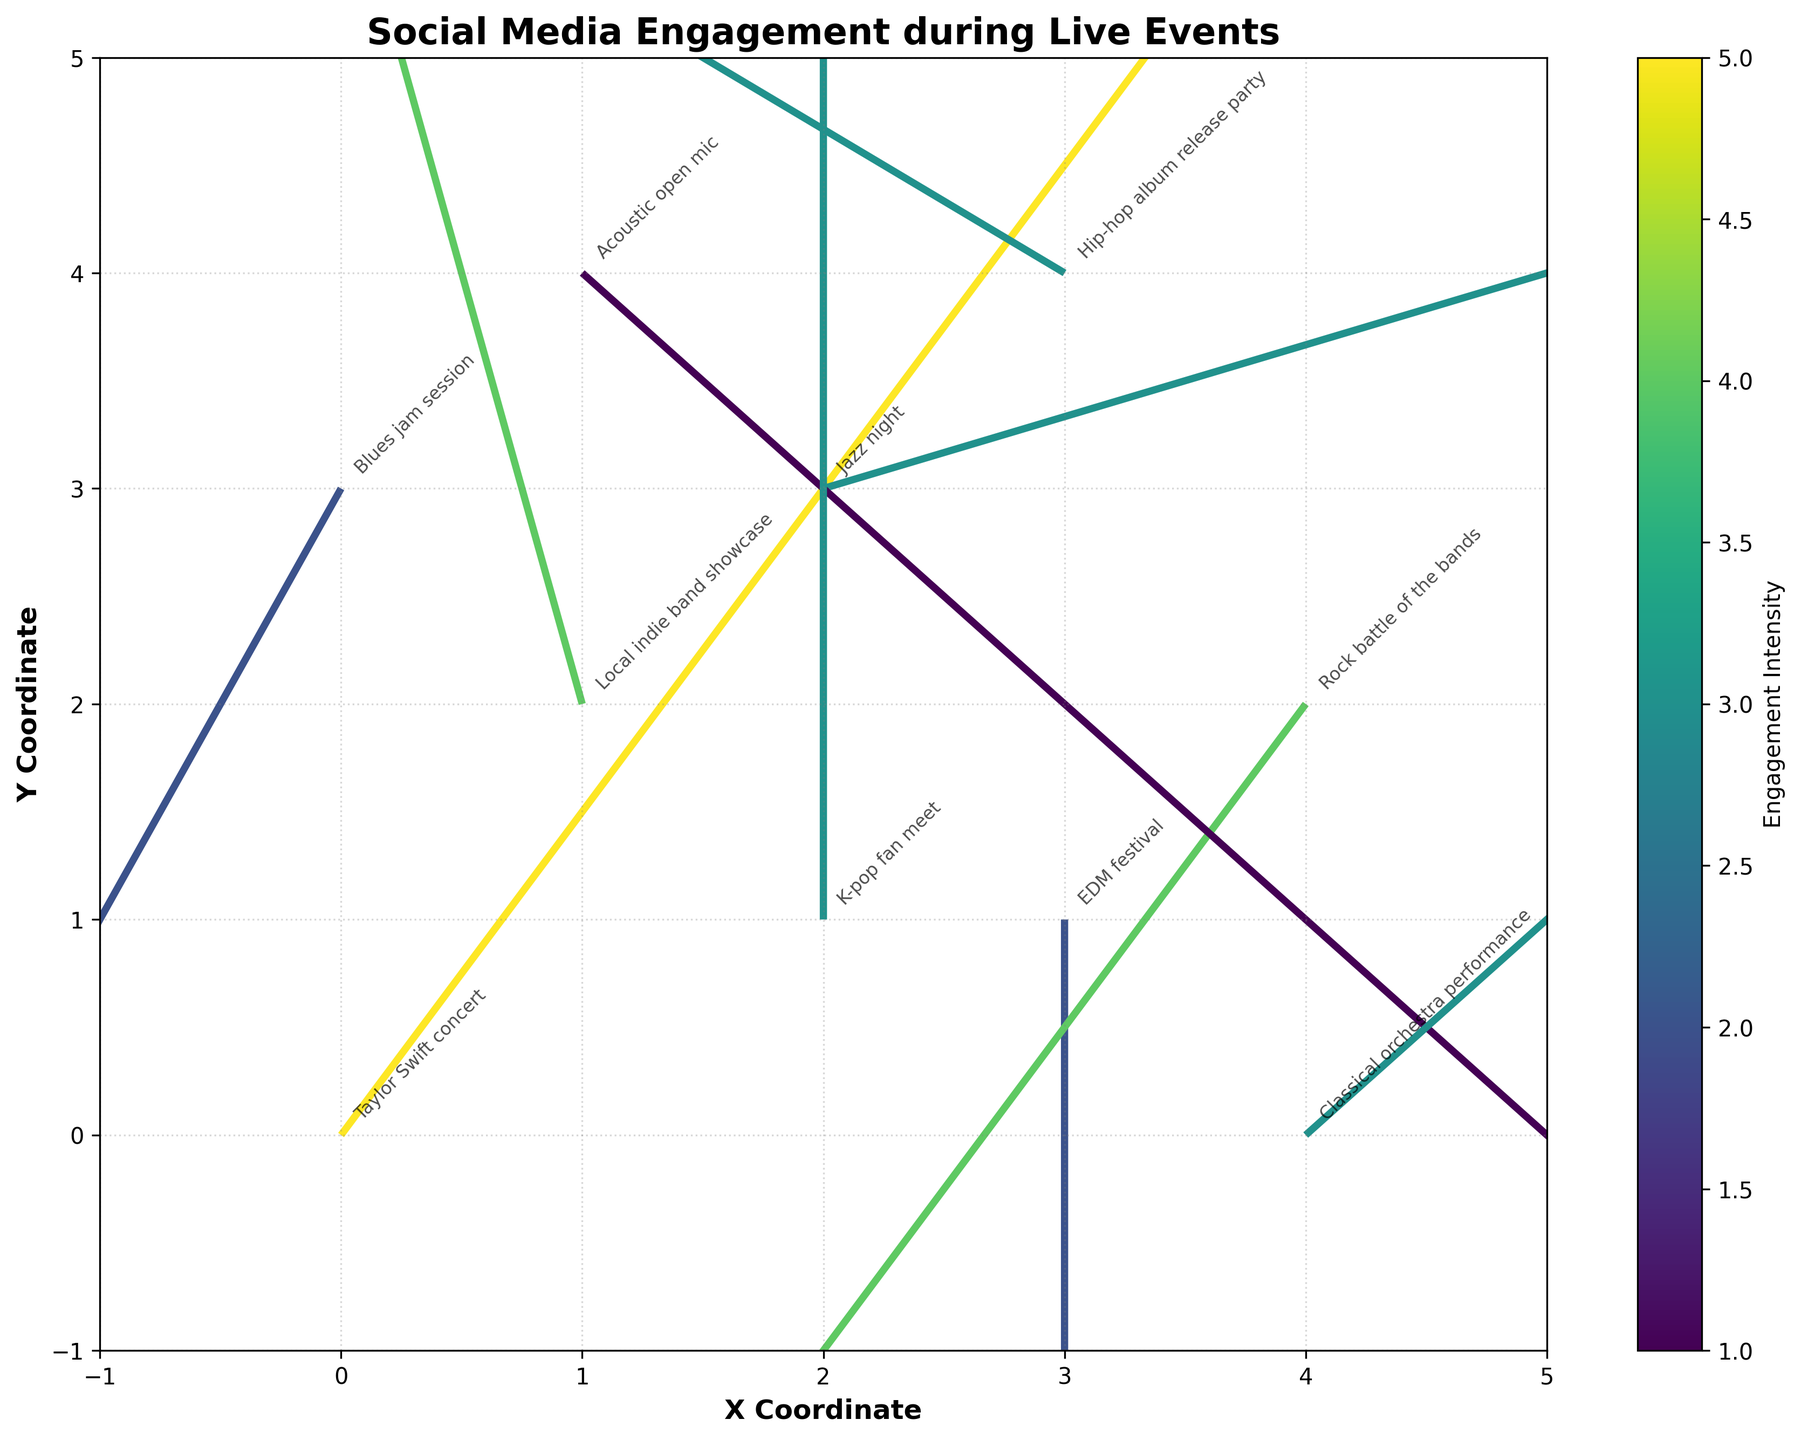What is the title of the plot? The title is located at the top of the plot and is written in a larger, bold font. It reads "Social Media Engagement during Live Events" in the given code.
Answer: Social Media Engagement during Live Events How many data points are represented in the plot? Each data point is represented by a quiver (arrow) on the plot. By counting all the arrows, we can determine the number of data points. There are 10 arrows, so there are 10 data points.
Answer: 10 What event has the highest engagement intensity? The color intensity helps to identify the magnitude of engagement, and each quiver is colored according to its magnitude. By looking closely at the color scale, we can see that the Taylor Swift concert has the highest magnitude of 5.
Answer: Taylor Swift concert Which events are represented in the plot? Each event is labeled on the plot with annotations. By reading these labels, we can identify all the events: Taylor Swift concert, Local indie band showcase, EDM festival, Jazz night, Rock battle of the bands, Acoustic open mic, Hip-hop album release party, Classical orchestra performance, K-pop fan meet, and Blues jam session.
Answer: Taylor Swift concert, Local indie band showcase, EDM festival, Jazz night, Rock battle of the bands, Acoustic open mic, Hip-hop album release party, Classical orchestra performance, K-pop fan meet, Blues jam session Which event has the largest upward social media interaction? Upward social media interaction is indicated by the upward direction of the quiver (positive v component). By inspecting the arrows, we see that the Local indie band showcase has the largest upward vector, with a v component of 4.
Answer: Local indie band showcase Compare the magnitude of engagement between "Jazz night" and "Hip-hop album release party". Which event has a higher engagement intensity? We need to compare the magnitudes of these two quivers. According to the data, "Jazz night" has a magnitude of 3 and "Hip-hop album release party" has a magnitude of 3 as well. Both events have equal engagement intensity.
Answer: Both have equal engagement intensity What is the average engagement intensity of all the events? To find the average engagement intensity, sum up all the magnitudes and divide by the number of data points (10). The magnitudes are 5, 4, 2, 3, 4, 1, 3, 3, 3, 2. Summing these gives 30. Dividing by 10, the average is 30/10 = 3.
Answer: 3 Which event has a negative direction in both the x and y coordinates? Negative direction in both x and y coordinates is indicated by the quiver pointing to the bottom-left quadrant. By checking the vectors, we see that "Rock battle of the bands" has a direction of (-2, -3), which is negative in both x and y directions.
Answer: Rock battle of the bands Do any events have a zero component in either axis? If so, which ones? We look for quivers that have a zero value in either the x (u) or y (v) component. "EDM festival" has a u component of 0, "Jazz night" has a v component of 0, and "K-pop fan meet" has a u component of 0.
Answer: EDM festival, Jazz night, K-pop fan meet Which event has the smallest magnitude of engagement, and what is the value? The smallest magnitude is represented by the least intense color on the color scale. The "Acoustic open mic" event has a magnitude value of 1, making it the smallest engagement intensity.
Answer: Acoustic open mic, 1 